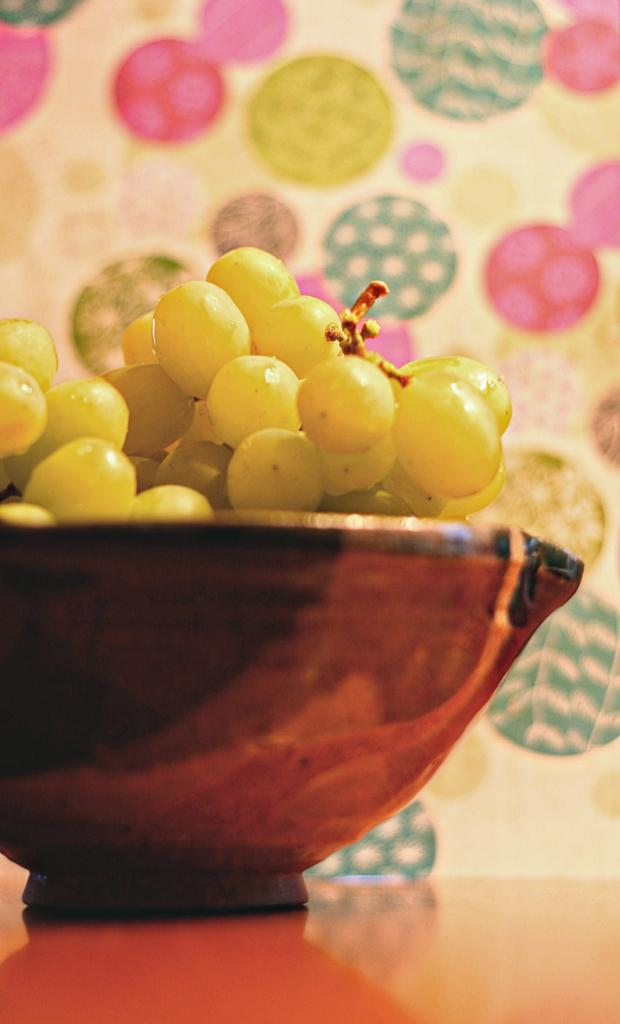What is in the bowl that is visible in the image? There is a bowl with grapes in the image. Where is the bowl located in the image? The bowl is placed on a table. Can you describe the background of the image? The background of the image has a multi-colored design. What type of flowers are being used to create the prose in the image? There are no flowers or prose present in the image; it features a bowl of grapes on a table with a multi-colored background. 